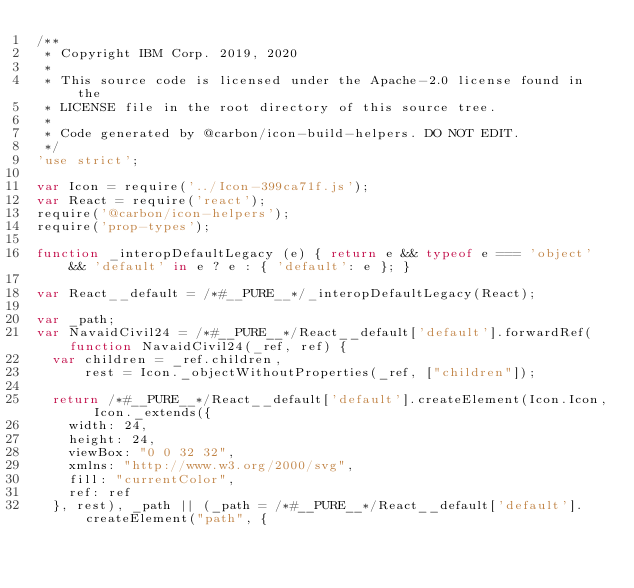<code> <loc_0><loc_0><loc_500><loc_500><_JavaScript_>/**
 * Copyright IBM Corp. 2019, 2020
 *
 * This source code is licensed under the Apache-2.0 license found in the
 * LICENSE file in the root directory of this source tree.
 *
 * Code generated by @carbon/icon-build-helpers. DO NOT EDIT.
 */
'use strict';

var Icon = require('../Icon-399ca71f.js');
var React = require('react');
require('@carbon/icon-helpers');
require('prop-types');

function _interopDefaultLegacy (e) { return e && typeof e === 'object' && 'default' in e ? e : { 'default': e }; }

var React__default = /*#__PURE__*/_interopDefaultLegacy(React);

var _path;
var NavaidCivil24 = /*#__PURE__*/React__default['default'].forwardRef(function NavaidCivil24(_ref, ref) {
  var children = _ref.children,
      rest = Icon._objectWithoutProperties(_ref, ["children"]);

  return /*#__PURE__*/React__default['default'].createElement(Icon.Icon, Icon._extends({
    width: 24,
    height: 24,
    viewBox: "0 0 32 32",
    xmlns: "http://www.w3.org/2000/svg",
    fill: "currentColor",
    ref: ref
  }, rest), _path || (_path = /*#__PURE__*/React__default['default'].createElement("path", {</code> 